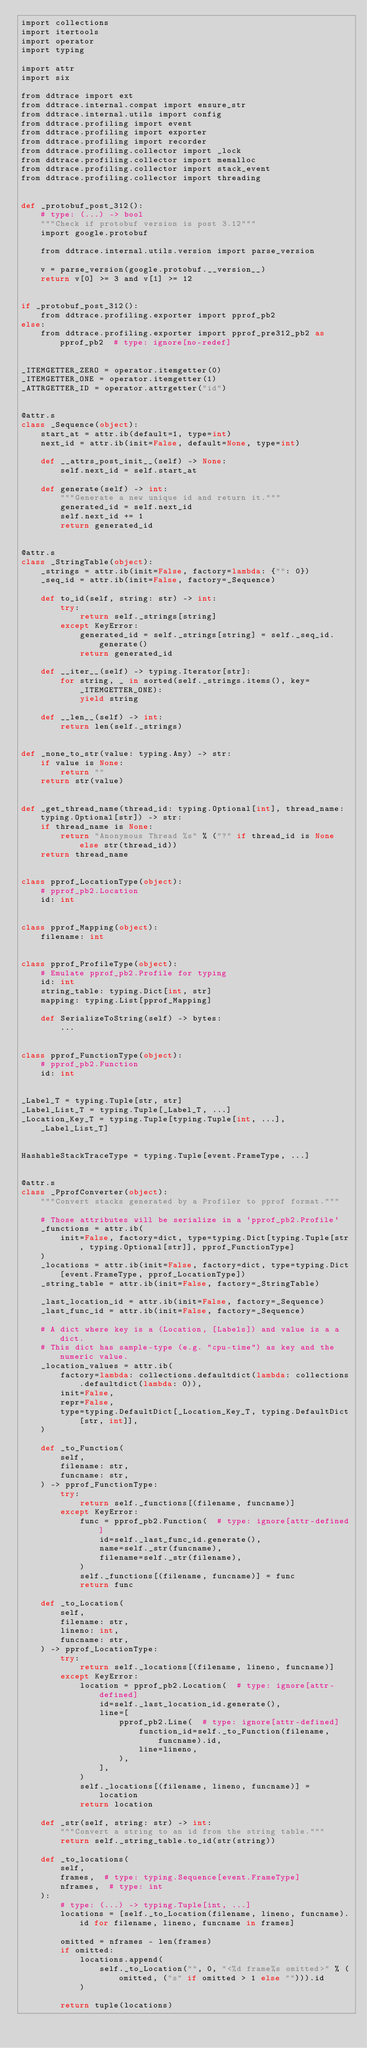<code> <loc_0><loc_0><loc_500><loc_500><_Cython_>import collections
import itertools
import operator
import typing

import attr
import six

from ddtrace import ext
from ddtrace.internal.compat import ensure_str
from ddtrace.internal.utils import config
from ddtrace.profiling import event
from ddtrace.profiling import exporter
from ddtrace.profiling import recorder
from ddtrace.profiling.collector import _lock
from ddtrace.profiling.collector import memalloc
from ddtrace.profiling.collector import stack_event
from ddtrace.profiling.collector import threading


def _protobuf_post_312():
    # type: (...) -> bool
    """Check if protobuf version is post 3.12"""
    import google.protobuf

    from ddtrace.internal.utils.version import parse_version

    v = parse_version(google.protobuf.__version__)
    return v[0] >= 3 and v[1] >= 12


if _protobuf_post_312():
    from ddtrace.profiling.exporter import pprof_pb2
else:
    from ddtrace.profiling.exporter import pprof_pre312_pb2 as pprof_pb2  # type: ignore[no-redef]


_ITEMGETTER_ZERO = operator.itemgetter(0)
_ITEMGETTER_ONE = operator.itemgetter(1)
_ATTRGETTER_ID = operator.attrgetter("id")


@attr.s
class _Sequence(object):
    start_at = attr.ib(default=1, type=int)
    next_id = attr.ib(init=False, default=None, type=int)

    def __attrs_post_init__(self) -> None:
        self.next_id = self.start_at

    def generate(self) -> int:
        """Generate a new unique id and return it."""
        generated_id = self.next_id
        self.next_id += 1
        return generated_id


@attr.s
class _StringTable(object):
    _strings = attr.ib(init=False, factory=lambda: {"": 0})
    _seq_id = attr.ib(init=False, factory=_Sequence)

    def to_id(self, string: str) -> int:
        try:
            return self._strings[string]
        except KeyError:
            generated_id = self._strings[string] = self._seq_id.generate()
            return generated_id

    def __iter__(self) -> typing.Iterator[str]:
        for string, _ in sorted(self._strings.items(), key=_ITEMGETTER_ONE):
            yield string

    def __len__(self) -> int:
        return len(self._strings)


def _none_to_str(value: typing.Any) -> str:
    if value is None:
        return ""
    return str(value)


def _get_thread_name(thread_id: typing.Optional[int], thread_name: typing.Optional[str]) -> str:
    if thread_name is None:
        return "Anonymous Thread %s" % ("?" if thread_id is None else str(thread_id))
    return thread_name


class pprof_LocationType(object):
    # pprof_pb2.Location
    id: int


class pprof_Mapping(object):
    filename: int


class pprof_ProfileType(object):
    # Emulate pprof_pb2.Profile for typing
    id: int
    string_table: typing.Dict[int, str]
    mapping: typing.List[pprof_Mapping]

    def SerializeToString(self) -> bytes:
        ...


class pprof_FunctionType(object):
    # pprof_pb2.Function
    id: int


_Label_T = typing.Tuple[str, str]
_Label_List_T = typing.Tuple[_Label_T, ...]
_Location_Key_T = typing.Tuple[typing.Tuple[int, ...], _Label_List_T]


HashableStackTraceType = typing.Tuple[event.FrameType, ...]


@attr.s
class _PprofConverter(object):
    """Convert stacks generated by a Profiler to pprof format."""

    # Those attributes will be serialize in a `pprof_pb2.Profile`
    _functions = attr.ib(
        init=False, factory=dict, type=typing.Dict[typing.Tuple[str, typing.Optional[str]], pprof_FunctionType]
    )
    _locations = attr.ib(init=False, factory=dict, type=typing.Dict[event.FrameType, pprof_LocationType])
    _string_table = attr.ib(init=False, factory=_StringTable)

    _last_location_id = attr.ib(init=False, factory=_Sequence)
    _last_func_id = attr.ib(init=False, factory=_Sequence)

    # A dict where key is a (Location, [Labels]) and value is a a dict.
    # This dict has sample-type (e.g. "cpu-time") as key and the numeric value.
    _location_values = attr.ib(
        factory=lambda: collections.defaultdict(lambda: collections.defaultdict(lambda: 0)),
        init=False,
        repr=False,
        type=typing.DefaultDict[_Location_Key_T, typing.DefaultDict[str, int]],
    )

    def _to_Function(
        self,
        filename: str,
        funcname: str,
    ) -> pprof_FunctionType:
        try:
            return self._functions[(filename, funcname)]
        except KeyError:
            func = pprof_pb2.Function(  # type: ignore[attr-defined]
                id=self._last_func_id.generate(),
                name=self._str(funcname),
                filename=self._str(filename),
            )
            self._functions[(filename, funcname)] = func
            return func

    def _to_Location(
        self,
        filename: str,
        lineno: int,
        funcname: str,
    ) -> pprof_LocationType:
        try:
            return self._locations[(filename, lineno, funcname)]
        except KeyError:
            location = pprof_pb2.Location(  # type: ignore[attr-defined]
                id=self._last_location_id.generate(),
                line=[
                    pprof_pb2.Line(  # type: ignore[attr-defined]
                        function_id=self._to_Function(filename, funcname).id,
                        line=lineno,
                    ),
                ],
            )
            self._locations[(filename, lineno, funcname)] = location
            return location

    def _str(self, string: str) -> int:
        """Convert a string to an id from the string table."""
        return self._string_table.to_id(str(string))

    def _to_locations(
        self,
        frames,  # type: typing.Sequence[event.FrameType]
        nframes,  # type: int
    ):
        # type: (...) -> typing.Tuple[int, ...]
        locations = [self._to_Location(filename, lineno, funcname).id for filename, lineno, funcname in frames]

        omitted = nframes - len(frames)
        if omitted:
            locations.append(
                self._to_Location("", 0, "<%d frame%s omitted>" % (omitted, ("s" if omitted > 1 else ""))).id
            )

        return tuple(locations)
</code> 